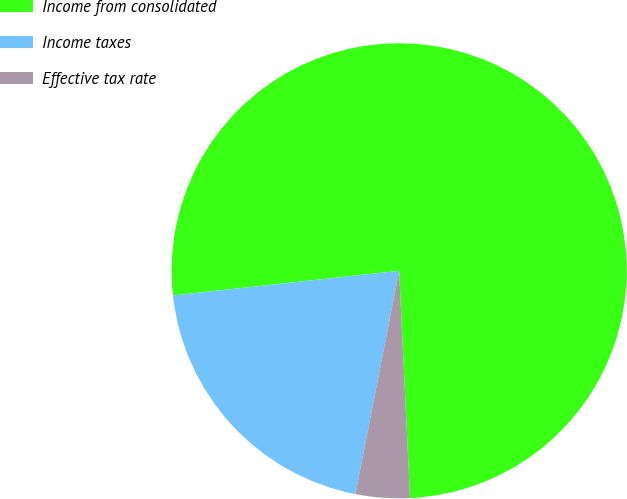Convert chart. <chart><loc_0><loc_0><loc_500><loc_500><pie_chart><fcel>Income from consolidated<fcel>Income taxes<fcel>Effective tax rate<nl><fcel>75.97%<fcel>20.19%<fcel>3.84%<nl></chart> 